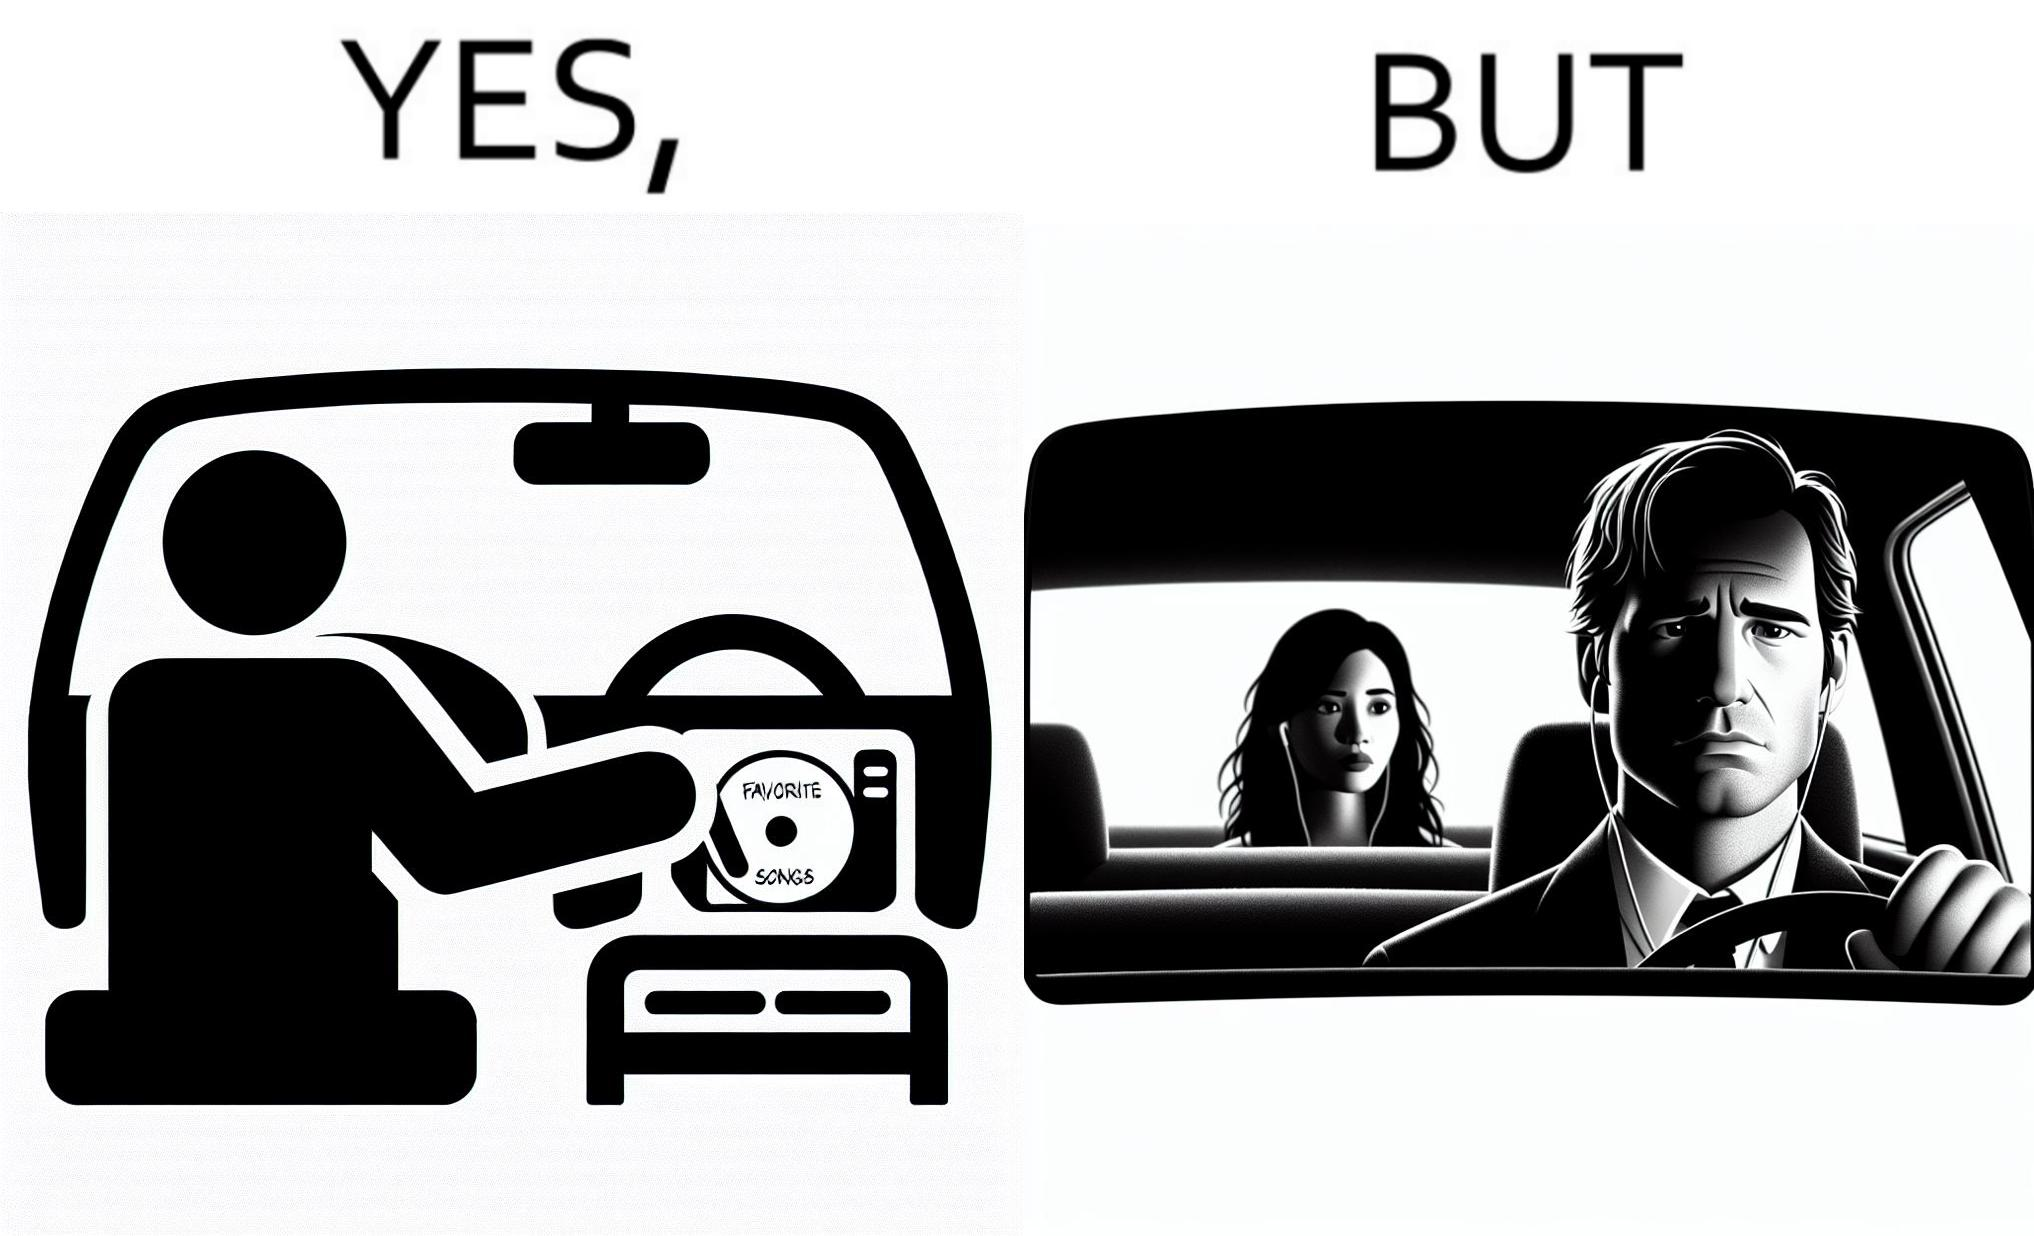Explain why this image is satirical. The image is funny, as the driver of the car inserts a CD named "Favorite Songs" into the CD player for the passenger, but the driver is sad on seeing the passenger in the back seat listening to something else on earphones instead. 